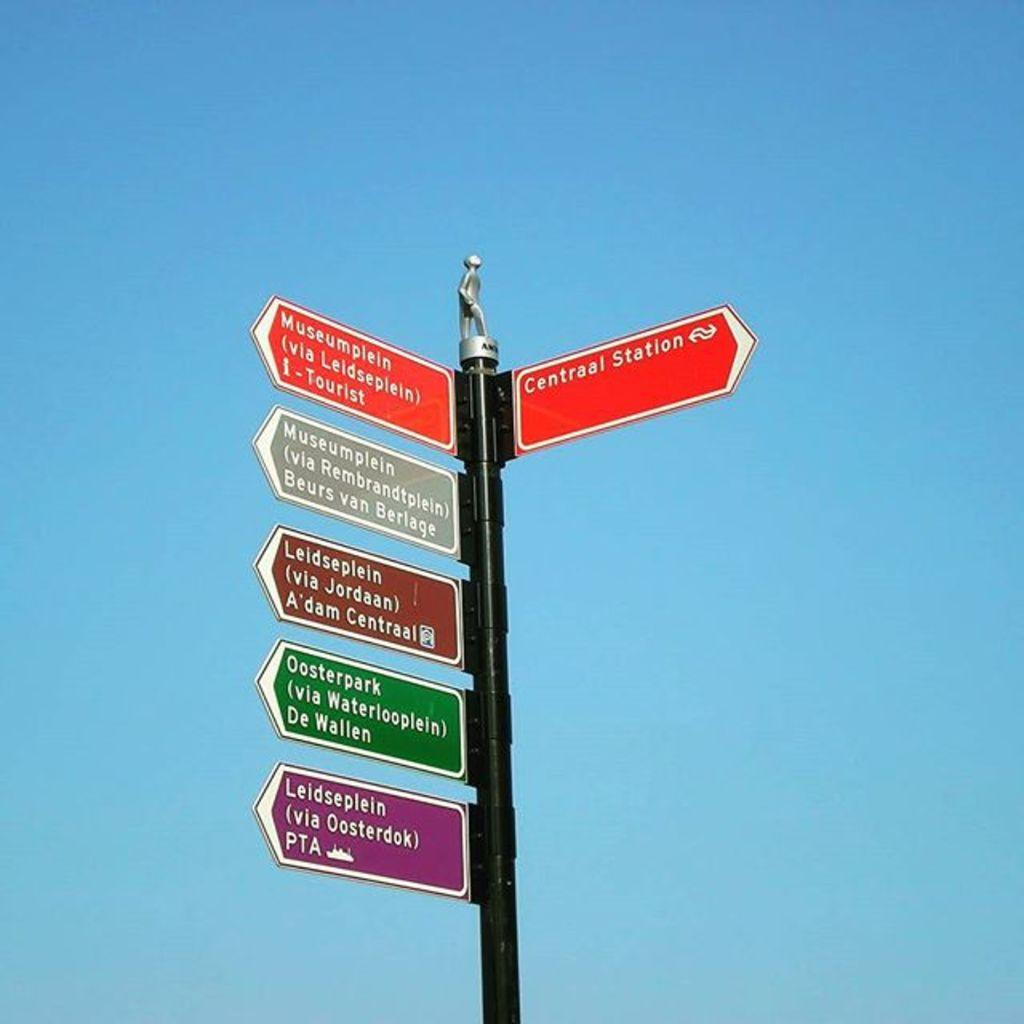<image>
Share a concise interpretation of the image provided. A sign shows the way to Centraal Station. 